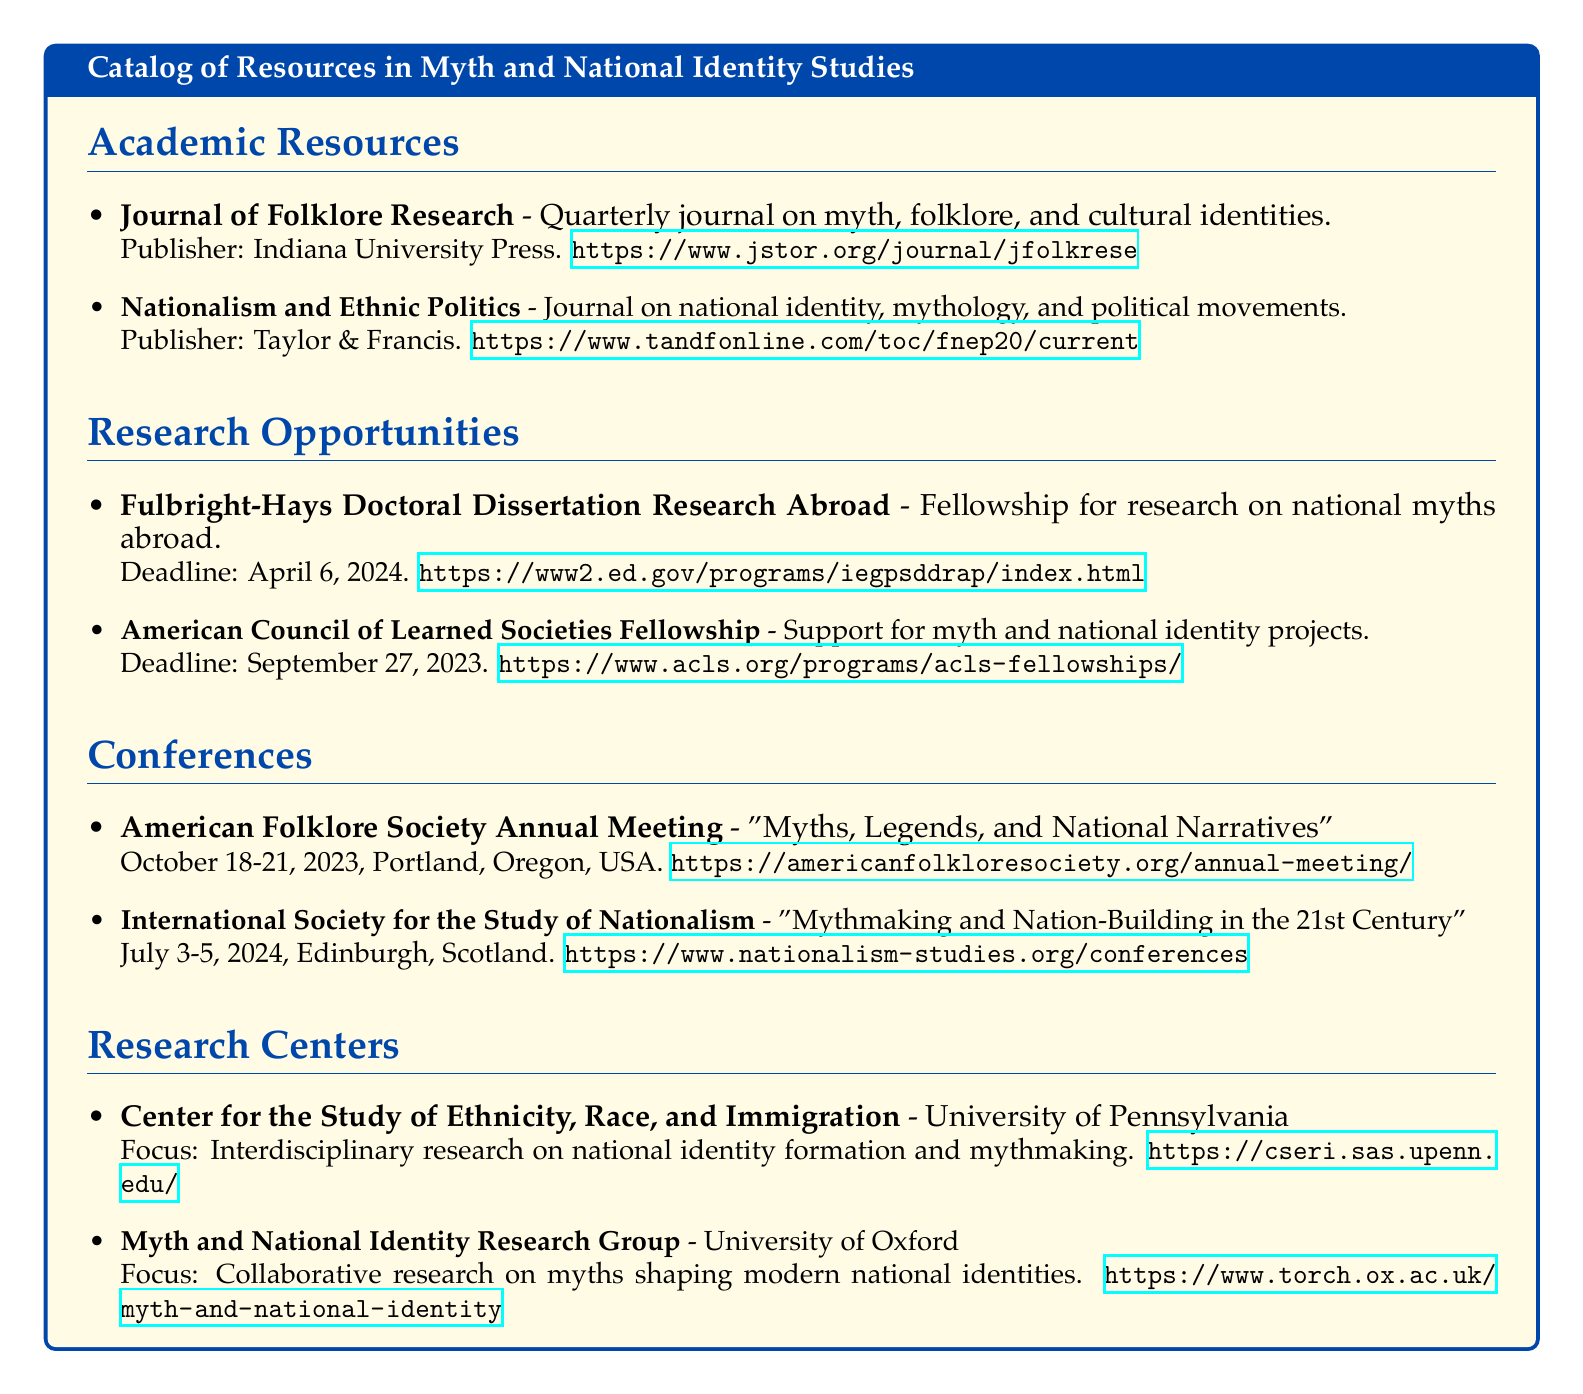What is the publisher of the Journal of Folklore Research? The publisher of the Journal of Folklore Research is Indiana University Press.
Answer: Indiana University Press What is the submission deadline for the Fulbright-Hays Fellowship? The deadline for the Fulbright-Hays Doctoral Dissertation Research Abroad is April 6, 2024.
Answer: April 6, 2024 Where is the American Folklore Society Annual Meeting held? The American Folklore Society Annual Meeting is held in Portland, Oregon, USA.
Answer: Portland, Oregon, USA Which research center focuses on interdisciplinary research on national identity formation? The Center for the Study of Ethnicity, Race, and Immigration focuses on interdisciplinary research on national identity formation.
Answer: Center for the Study of Ethnicity, Race, and Immigration What is the title of the conference scheduled for July 3-5, 2024? The title of the conference is "Mythmaking and Nation-Building in the 21st Century".
Answer: Mythmaking and Nation-Building in the 21st Century How often is the Journal of Folklore Research published? The Journal of Folklore Research is published quarterly.
Answer: Quarterly What is the focus of the Myth and National Identity Research Group? The focus of the Myth and National Identity Research Group is collaborative research on myths shaping modern national identities.
Answer: Collaborative research on myths shaping modern national identities What organization publishes the journal Nationalism and Ethnic Politics? The journal Nationalism and Ethnic Politics is published by Taylor & Francis.
Answer: Taylor & Francis What is the date for the American Council of Learned Societies Fellowship deadline? The date for the American Council of Learned Societies Fellowship deadline is September 27, 2023.
Answer: September 27, 2023 